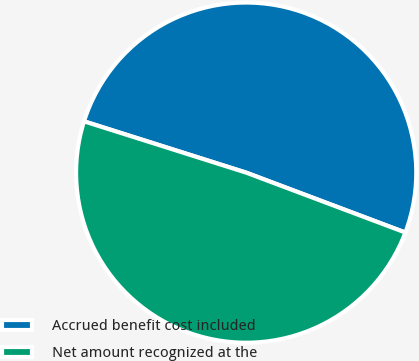<chart> <loc_0><loc_0><loc_500><loc_500><pie_chart><fcel>Accrued benefit cost included<fcel>Net amount recognized at the<nl><fcel>50.85%<fcel>49.15%<nl></chart> 